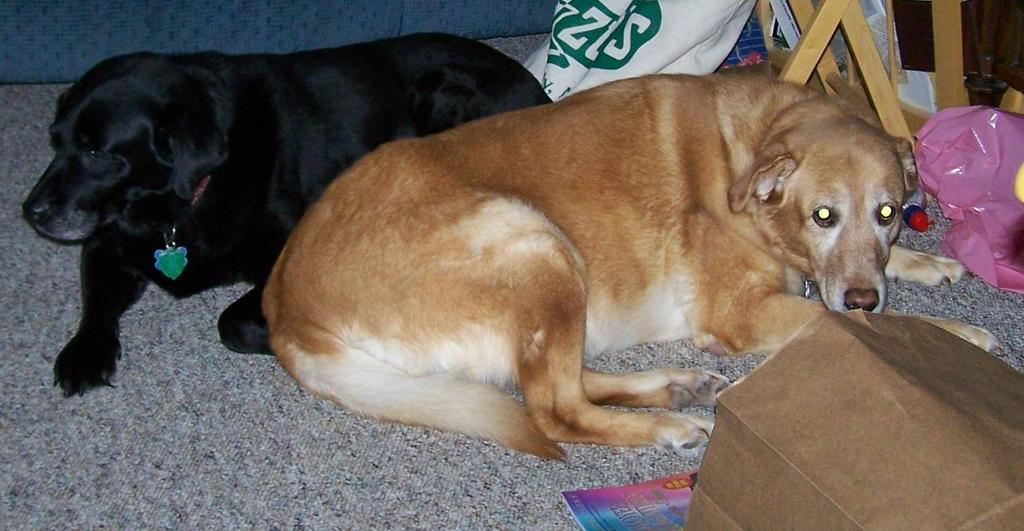How many dogs are in the image? There are 2 dogs in the image. What are the dogs doing in the image? The dogs are sitting on the floor. What colors are the dogs in the image? The dogs are black and brown in color. What else can be seen on the floor in the image? There are other objects on the floor. What type of honey is being used to paint the dogs in the image? There is no honey present in the image, and the dogs are not being painted. 